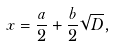<formula> <loc_0><loc_0><loc_500><loc_500>x = { \frac { a } { 2 } } + { \frac { b } { 2 } } { \sqrt { D } } ,</formula> 